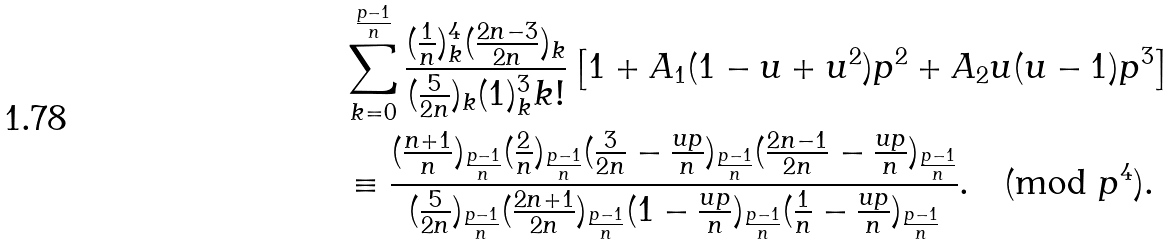Convert formula to latex. <formula><loc_0><loc_0><loc_500><loc_500>& \sum _ { k = 0 } ^ { \frac { p - 1 } { n } } \frac { ( \frac { 1 } { n } ) _ { k } ^ { 4 } ( \frac { 2 n - 3 } { 2 n } ) _ { k } } { ( \frac { 5 } { 2 n } ) _ { k } ( 1 ) _ { k } ^ { 3 } k ! } \left [ 1 + A _ { 1 } ( 1 - u + u ^ { 2 } ) p ^ { 2 } + A _ { 2 } u ( u - 1 ) p ^ { 3 } \right ] \\ & \equiv \frac { ( \frac { n + 1 } { n } ) _ { \frac { p - 1 } { n } } ( \frac { 2 } { n } ) _ { \frac { p - 1 } { n } } ( \frac { 3 } { 2 n } - \frac { u p } { n } ) _ { \frac { p - 1 } { n } } ( \frac { 2 n - 1 } { 2 n } - \frac { u p } { n } ) _ { \frac { p - 1 } { n } } } { ( \frac { 5 } { 2 n } ) _ { \frac { p - 1 } { n } } ( \frac { 2 n + 1 } { 2 n } ) _ { \frac { p - 1 } { n } } ( 1 - \frac { u p } { n } ) _ { \frac { p - 1 } { n } } ( \frac { 1 } { n } - \frac { u p } { n } ) _ { \frac { p - 1 } { n } } } . \pmod { p ^ { 4 } } .</formula> 